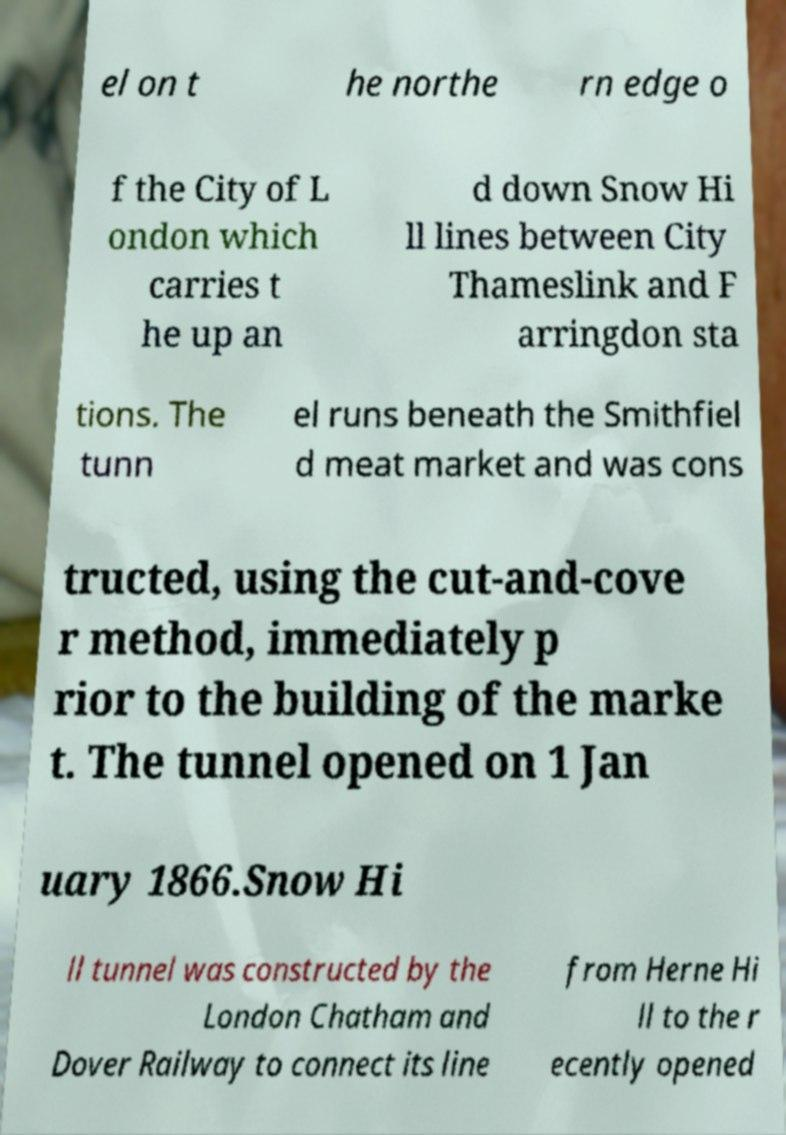I need the written content from this picture converted into text. Can you do that? el on t he northe rn edge o f the City of L ondon which carries t he up an d down Snow Hi ll lines between City Thameslink and F arringdon sta tions. The tunn el runs beneath the Smithfiel d meat market and was cons tructed, using the cut-and-cove r method, immediately p rior to the building of the marke t. The tunnel opened on 1 Jan uary 1866.Snow Hi ll tunnel was constructed by the London Chatham and Dover Railway to connect its line from Herne Hi ll to the r ecently opened 